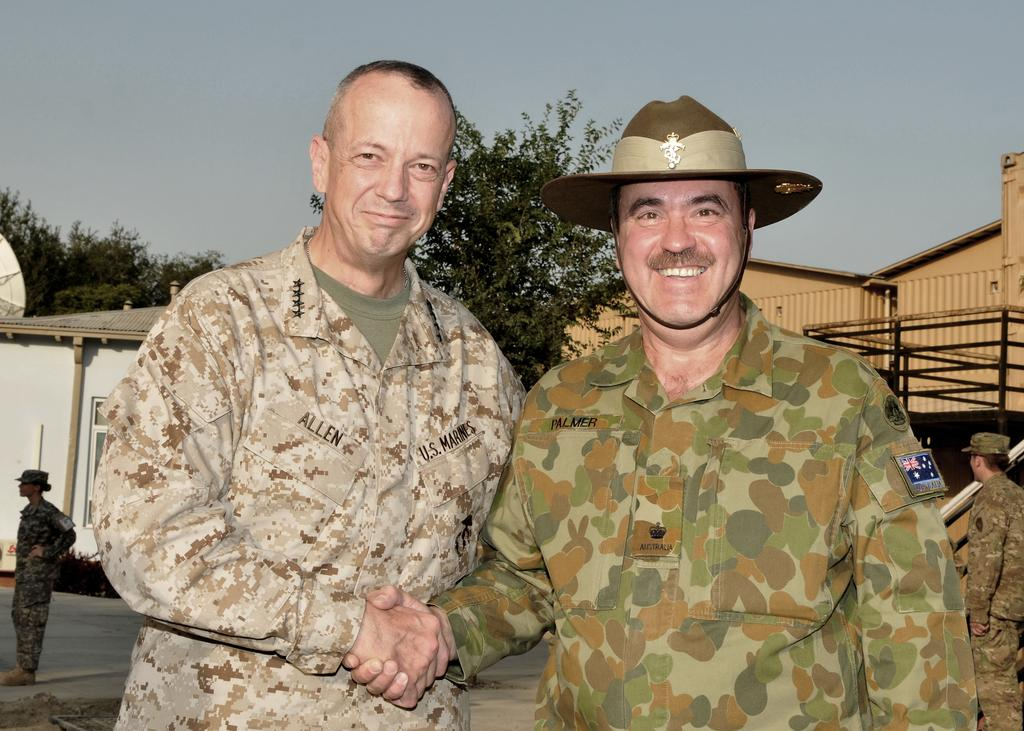What can be seen in the background of the image? There are buildings and trees in the background of the image. What are the people in the image doing? The woman is standing on the left side of the image, and the man is standing on the right side of the image. What is the condition of the sky in the image? The sky is cloudy in the image. What type of toys can be seen in the design of the minute hand on the clock in the image? There is no clock or minute hand present in the image, so it is not possible to determine what type of toys might be designed on it. 